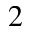Convert formula to latex. <formula><loc_0><loc_0><loc_500><loc_500>2</formula> 